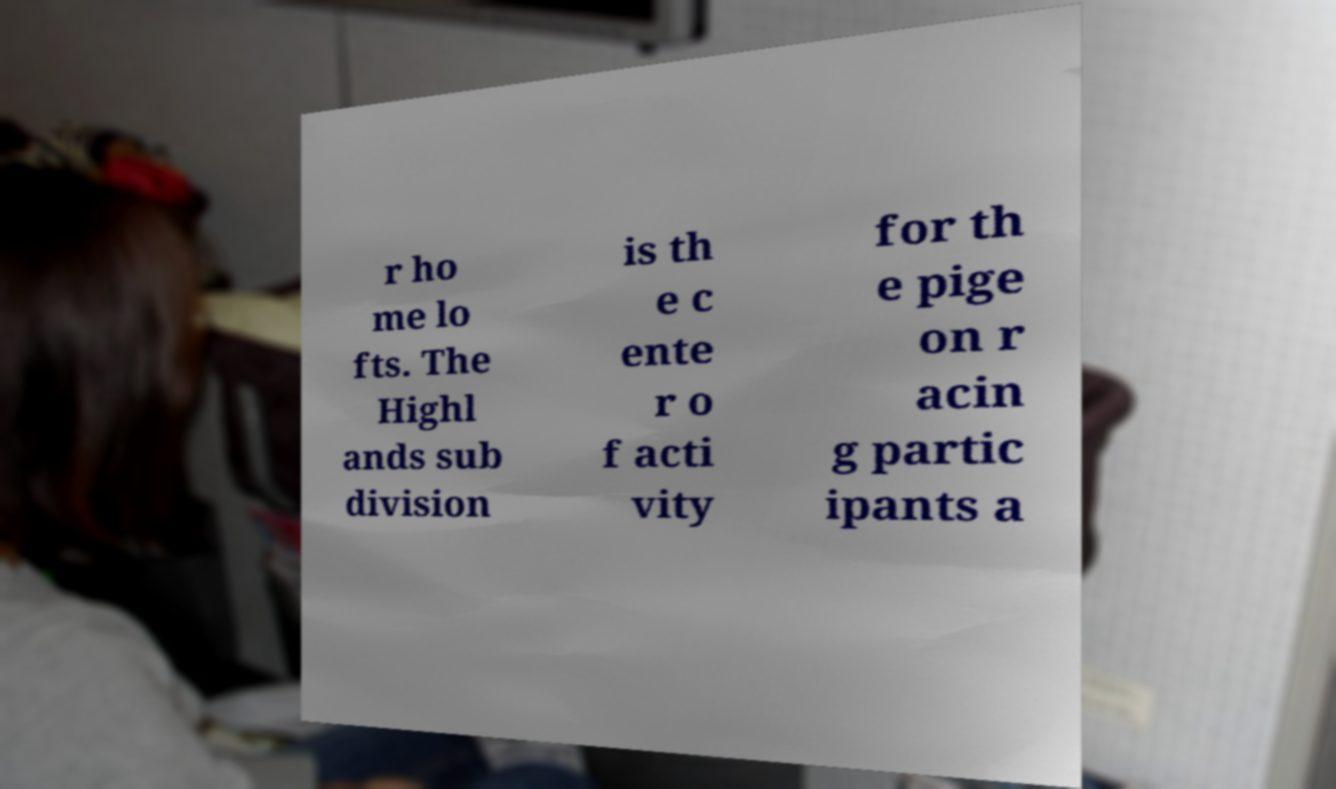Please read and relay the text visible in this image. What does it say? r ho me lo fts. The Highl ands sub division is th e c ente r o f acti vity for th e pige on r acin g partic ipants a 